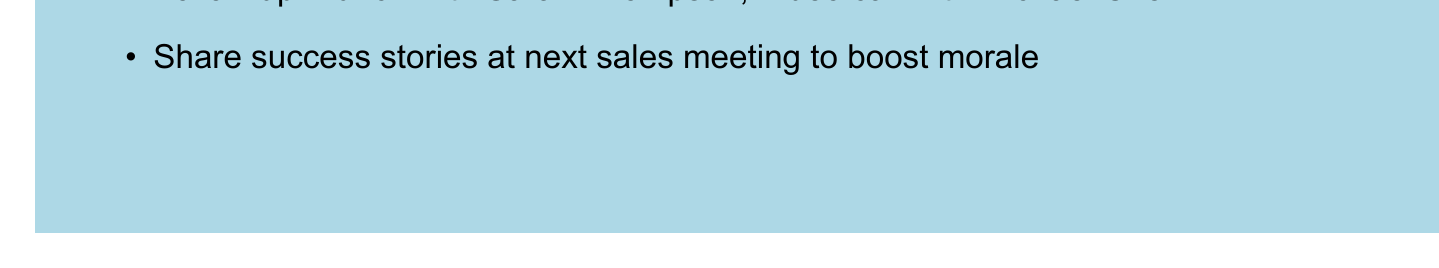What was the response rate for the survey? The response rate is calculated as the percentage of participants who responded to the survey, which is 78%.
Answer: 78% What is the average satisfaction rating from the survey? The average satisfaction rating is mentioned directly in the document as 8.2 out of 10.
Answer: 8.2/10 Which department is responsible for implementing the new customer support ticketing system? The document specifies that the IT Department is responsible for this action item.
Answer: IT Department What is the deadline for developing tailored pricing plans for small businesses? The deadline for this action item is explicitly stated in the document as August 15, 2023.
Answer: August 15, 2023 Which client mentioned the need for faster support response times? The client's quote about support response times attributes the comment to Sarah Thompson, the Marketing Director at TechNova Inc.
Answer: Sarah Thompson How much did the overall satisfaction score increase compared to Q1? The document mentions that the overall satisfaction score increased by 12%.
Answer: 12% What is one of the team celebration ideas proposed in the memo? The document lists ideas for celebrations, one being a pizza party.
Answer: Pizza party Who are mentioned as the top performers in the personal notes? The top performers are listed in the personal notes section of the document as Emily Rodriguez, David Park, and Samantha Lee.
Answer: Emily Rodriguez, David Park, Samantha Lee What initiative is planned to launch on September 1, 2023? The document states that 'Client Appreciation Week' initiative is set to be launched on this date.
Answer: Client Appreciation Week 